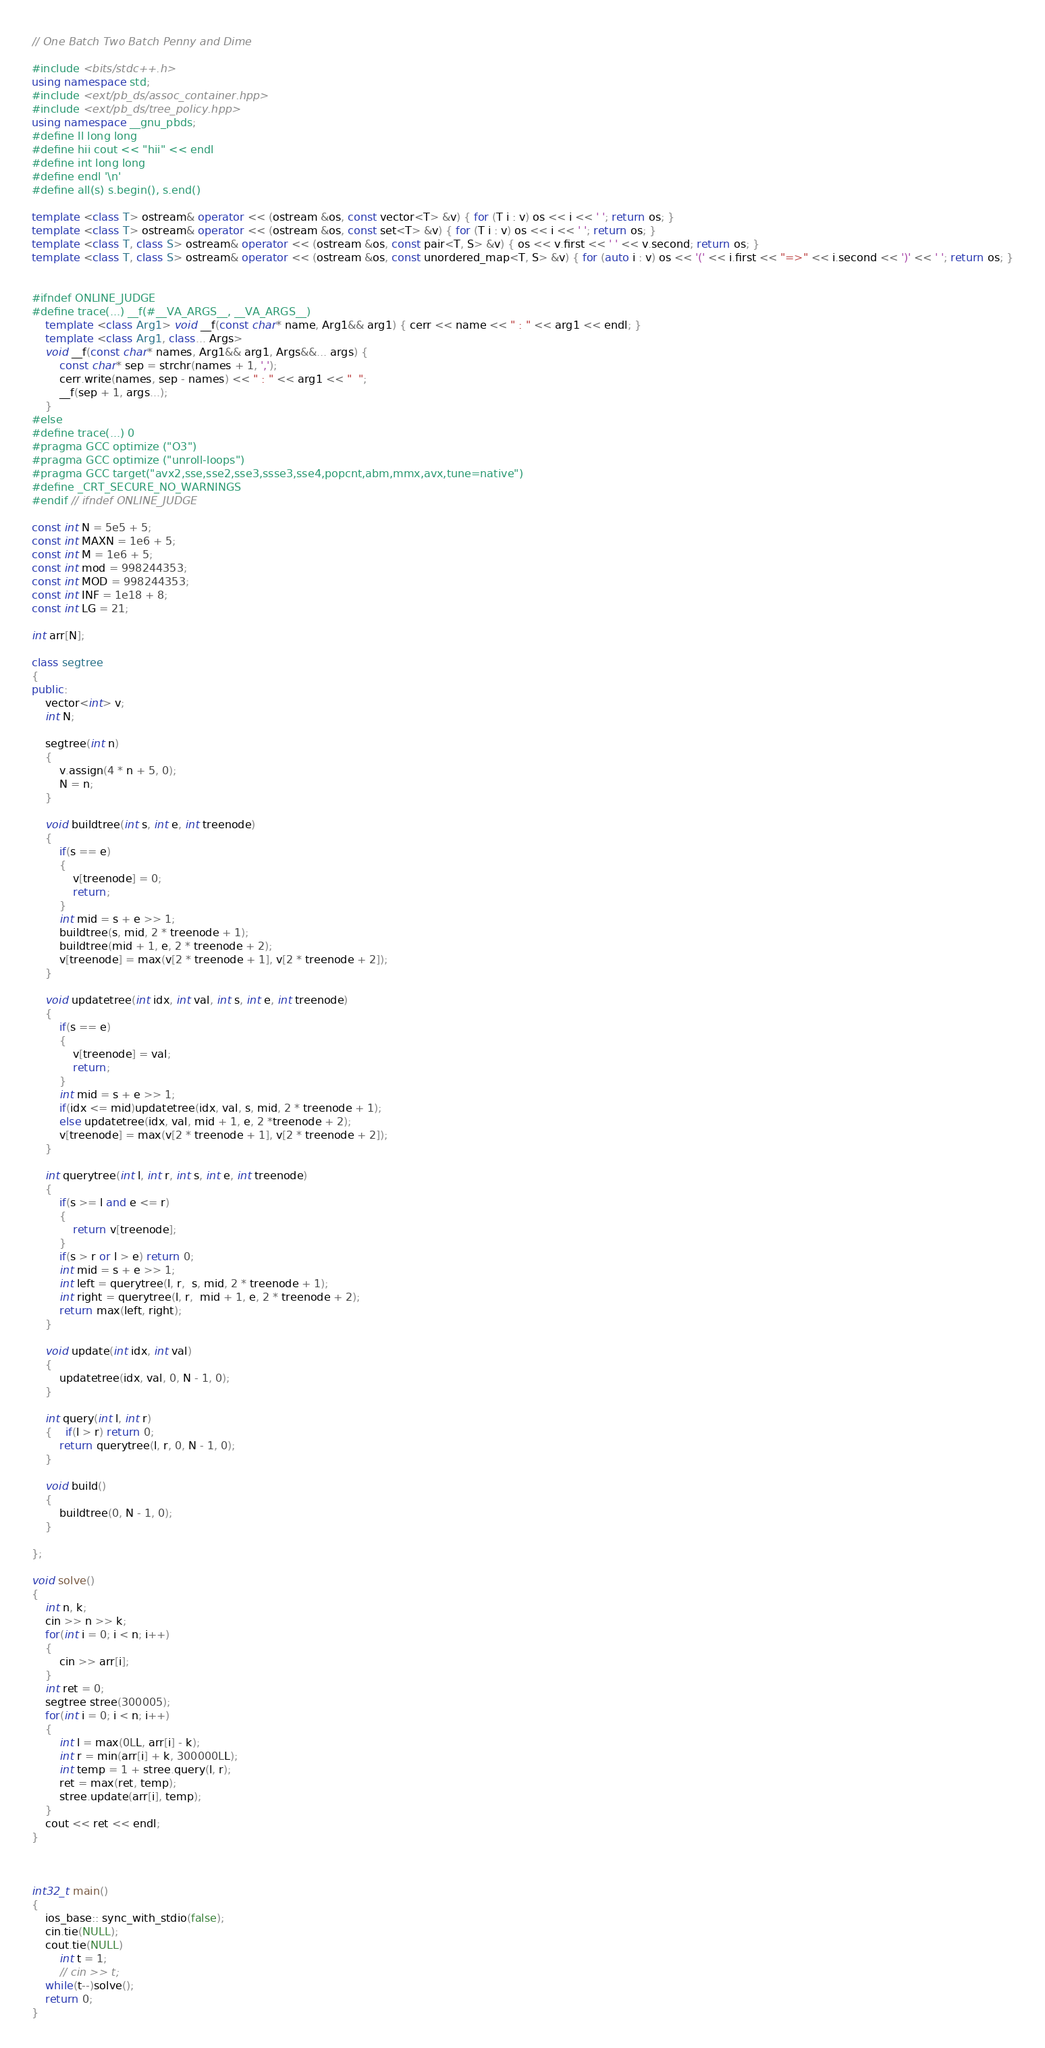Convert code to text. <code><loc_0><loc_0><loc_500><loc_500><_C++_>// One Batch Two Batch Penny and Dime

#include <bits/stdc++.h>
using namespace std;
#include <ext/pb_ds/assoc_container.hpp>
#include <ext/pb_ds/tree_policy.hpp>
using namespace __gnu_pbds;
#define ll long long
#define hii cout << "hii" << endl
#define int long long
#define endl '\n'
#define all(s) s.begin(), s.end()
 
template <class T> ostream& operator << (ostream &os, const vector<T> &v) { for (T i : v) os << i << ' '; return os; }
template <class T> ostream& operator << (ostream &os, const set<T> &v) { for (T i : v) os << i << ' '; return os; }
template <class T, class S> ostream& operator << (ostream &os, const pair<T, S> &v) { os << v.first << ' ' << v.second; return os; }
template <class T, class S> ostream& operator << (ostream &os, const unordered_map<T, S> &v) { for (auto i : v) os << '(' << i.first << "=>" << i.second << ')' << ' '; return os; }
 
 
#ifndef ONLINE_JUDGE
#define trace(...) __f(#__VA_ARGS__, __VA_ARGS__)
    template <class Arg1> void __f(const char* name, Arg1&& arg1) { cerr << name << " : " << arg1 << endl; }
    template <class Arg1, class... Args>
    void __f(const char* names, Arg1&& arg1, Args&&... args) {
        const char* sep = strchr(names + 1, ',');
        cerr.write(names, sep - names) << " : " << arg1 << "  ";
        __f(sep + 1, args...);
    }
#else
#define trace(...) 0
#pragma GCC optimize ("O3")
#pragma GCC optimize ("unroll-loops")
#pragma GCC target("avx2,sse,sse2,sse3,ssse3,sse4,popcnt,abm,mmx,avx,tune=native")
#define _CRT_SECURE_NO_WARNINGS
#endif // ifndef ONLINE_JUDGE

const int N = 5e5 + 5;
const int MAXN = 1e6 + 5;
const int M = 1e6 + 5;
const int mod = 998244353;
const int MOD = 998244353;
const int INF = 1e18 + 8;
const int LG = 21;

int arr[N];
 
class segtree
{
public:
	vector<int> v;
	int N;
 
	segtree(int n)
	{
		v.assign(4 * n + 5, 0);
		N = n;
	}
 
	void buildtree(int s, int e, int treenode)
	{
		if(s == e)
		{
			v[treenode] = 0;
			return;
		}
		int mid = s + e >> 1;
		buildtree(s, mid, 2 * treenode + 1);
		buildtree(mid + 1, e, 2 * treenode + 2);
		v[treenode] = max(v[2 * treenode + 1], v[2 * treenode + 2]);
	}
 
	void updatetree(int idx, int val, int s, int e, int treenode)
	{
		if(s == e)
		{
			v[treenode] = val;
			return;
		}
		int mid = s + e >> 1;
		if(idx <= mid)updatetree(idx, val, s, mid, 2 * treenode + 1);
		else updatetree(idx, val, mid + 1, e, 2 *treenode + 2);
		v[treenode] = max(v[2 * treenode + 1], v[2 * treenode + 2]);
	}
 
	int querytree(int l, int r, int s, int e, int treenode)
	{
		if(s >= l and e <= r)
	    {
	        return v[treenode];
	    }
	    if(s > r or l > e) return 0;
	    int mid = s + e >> 1;
	    int left = querytree(l, r,  s, mid, 2 * treenode + 1);
	    int right = querytree(l, r,  mid + 1, e, 2 * treenode + 2);
	    return max(left, right);
	}
 
	void update(int idx, int val)
	{
		updatetree(idx, val, 0, N - 1, 0);
	}
 
	int query(int l, int r)
	{	if(l > r) return 0;
		return querytree(l, r, 0, N - 1, 0);
	}
 
	void build()
	{
		buildtree(0, N - 1, 0);
	}
 
};

void solve()
{
	int n, k;
	cin >> n >> k;
	for(int i = 0; i < n; i++)
	{
		cin >> arr[i];
	}
	int ret = 0;
	segtree stree(300005);
	for(int i = 0; i < n; i++)
	{
		int l = max(0LL, arr[i] - k);
		int r = min(arr[i] + k, 300000LL);
		int temp = 1 + stree.query(l, r);
		ret = max(ret, temp);
		stree.update(arr[i], temp);
	}
	cout << ret << endl;
}


 
int32_t main() 
{	
	ios_base:: sync_with_stdio(false);
	cin.tie(NULL);
	cout.tie(NULL)
	    int t = 1;
	    // cin >> t;
	while(t--)solve();
	return 0;
}</code> 